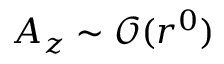<formula> <loc_0><loc_0><loc_500><loc_500>A _ { z } \sim \mathcal { O } ( r ^ { 0 } )</formula> 